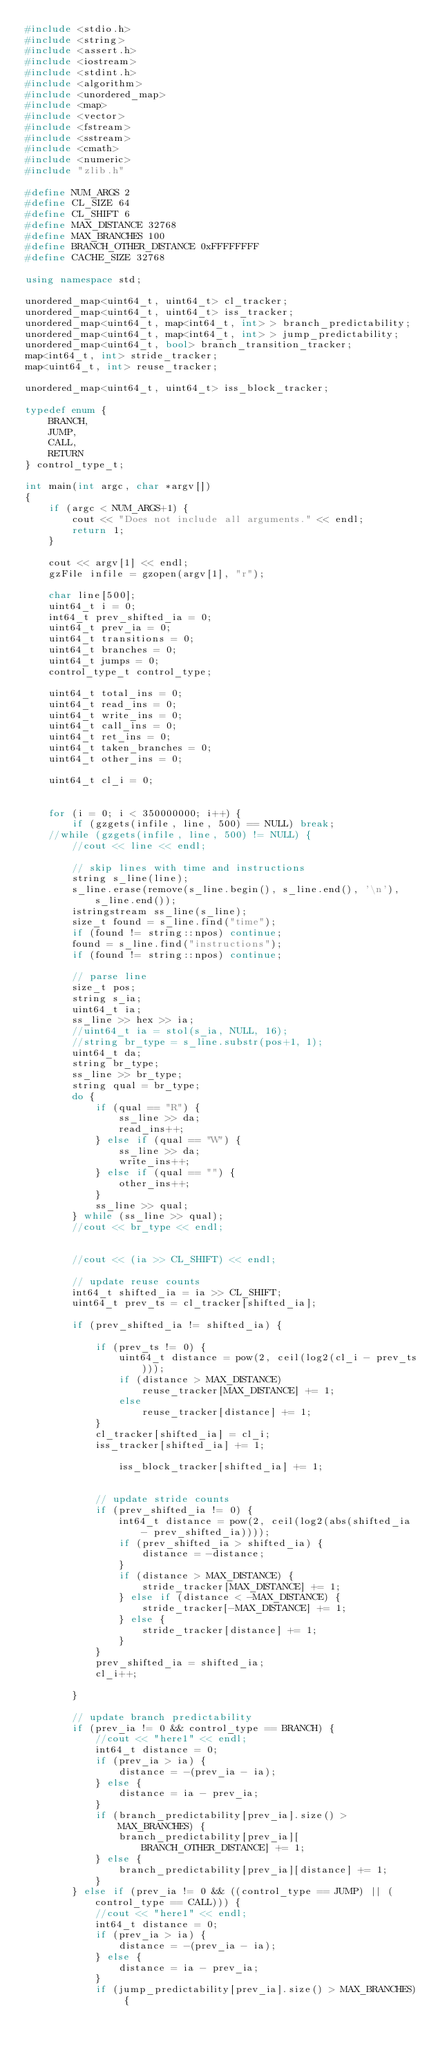Convert code to text. <code><loc_0><loc_0><loc_500><loc_500><_C++_>#include <stdio.h>
#include <string>
#include <assert.h>
#include <iostream>
#include <stdint.h>
#include <algorithm>
#include <unordered_map>
#include <map>
#include <vector>
#include <fstream>
#include <sstream>
#include <cmath>
#include <numeric>
#include "zlib.h"

#define NUM_ARGS 2
#define CL_SIZE 64
#define CL_SHIFT 6
#define MAX_DISTANCE 32768
#define MAX_BRANCHES 100
#define BRANCH_OTHER_DISTANCE 0xFFFFFFFF
#define CACHE_SIZE 32768

using namespace std;

unordered_map<uint64_t, uint64_t> cl_tracker;
unordered_map<uint64_t, uint64_t> iss_tracker;
unordered_map<uint64_t, map<int64_t, int> > branch_predictability;
unordered_map<uint64_t, map<int64_t, int> > jump_predictability;
unordered_map<uint64_t, bool> branch_transition_tracker;
map<int64_t, int> stride_tracker;
map<uint64_t, int> reuse_tracker;

unordered_map<uint64_t, uint64_t> iss_block_tracker;

typedef enum {
	BRANCH,
	JUMP,
	CALL,
	RETURN
} control_type_t;

int main(int argc, char *argv[])
{
	if (argc < NUM_ARGS+1) {
		cout << "Does not include all arguments." << endl;
		return 1;
	}

	cout << argv[1] << endl;
	gzFile infile = gzopen(argv[1], "r");

	char line[500];
	uint64_t i = 0;
	int64_t prev_shifted_ia = 0;
	uint64_t prev_ia = 0;
	uint64_t transitions = 0;
	uint64_t branches = 0;
	uint64_t jumps = 0;
	control_type_t control_type;

	uint64_t total_ins = 0;
	uint64_t read_ins = 0;
	uint64_t write_ins = 0;
	uint64_t call_ins = 0;
	uint64_t ret_ins = 0;
	uint64_t taken_branches = 0;
	uint64_t other_ins = 0;

	uint64_t cl_i = 0;


	for (i = 0; i < 350000000; i++) {
		if (gzgets(infile, line, 500) == NULL) break;
	//while (gzgets(infile, line, 500) != NULL) {
		//cout << line << endl;

		// skip lines with time and instructions
		string s_line(line);
		s_line.erase(remove(s_line.begin(), s_line.end(), '\n'), s_line.end());
		istringstream ss_line(s_line);
		size_t found = s_line.find("time");
		if (found != string::npos) continue;
		found = s_line.find("instructions");
		if (found != string::npos) continue;

		// parse line
		size_t pos;
		string s_ia;
		uint64_t ia;
		ss_line >> hex >> ia;
		//uint64_t ia = stol(s_ia, NULL, 16);
		//string br_type = s_line.substr(pos+1, 1);
		uint64_t da;
		string br_type;
		ss_line >> br_type;
		string qual = br_type;
		do {
			if (qual == "R") {
				ss_line >> da;
				read_ins++;
			} else if (qual == "W") {
				ss_line >> da;
				write_ins++;
			} else if (qual == "") {
				other_ins++;
			}
			ss_line >> qual;
		} while (ss_line >> qual);
		//cout << br_type << endl;


		//cout << (ia >> CL_SHIFT) << endl;

		// update reuse counts
		int64_t shifted_ia = ia >> CL_SHIFT;
		uint64_t prev_ts = cl_tracker[shifted_ia];

		if (prev_shifted_ia != shifted_ia) {

			if (prev_ts != 0) {
				uint64_t distance = pow(2, ceil(log2(cl_i - prev_ts)));
				if (distance > MAX_DISTANCE)
					reuse_tracker[MAX_DISTANCE] += 1;
				else
					reuse_tracker[distance] += 1;
			}
			cl_tracker[shifted_ia] = cl_i;
			iss_tracker[shifted_ia] += 1;
			
				iss_block_tracker[shifted_ia] += 1;


			// update stride counts
			if (prev_shifted_ia != 0) {
				int64_t distance = pow(2, ceil(log2(abs(shifted_ia - prev_shifted_ia))));
				if (prev_shifted_ia > shifted_ia) {
					distance = -distance;
				}
				if (distance > MAX_DISTANCE) {
					stride_tracker[MAX_DISTANCE] += 1;
				} else if (distance < -MAX_DISTANCE) {
					stride_tracker[-MAX_DISTANCE] += 1;
				} else {
					stride_tracker[distance] += 1;
				}
			}
			prev_shifted_ia = shifted_ia;
			cl_i++;

		}

		// update branch predictability
		if (prev_ia != 0 && control_type == BRANCH) {
			//cout << "here1" << endl;
			int64_t distance = 0;
			if (prev_ia > ia) {
				distance = -(prev_ia - ia);
			} else {
				distance = ia - prev_ia;
			}
			if (branch_predictability[prev_ia].size() > MAX_BRANCHES) {
				branch_predictability[prev_ia][BRANCH_OTHER_DISTANCE] += 1;
			} else {
				branch_predictability[prev_ia][distance] += 1;
			}
		} else if (prev_ia != 0 && ((control_type == JUMP) || (control_type == CALL))) {
			//cout << "here1" << endl;
			int64_t distance = 0;
			if (prev_ia > ia) {
				distance = -(prev_ia - ia);
			} else {
				distance = ia - prev_ia;
			}
			if (jump_predictability[prev_ia].size() > MAX_BRANCHES) {</code> 